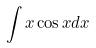Convert formula to latex. <formula><loc_0><loc_0><loc_500><loc_500>\int x \cos x d x</formula> 